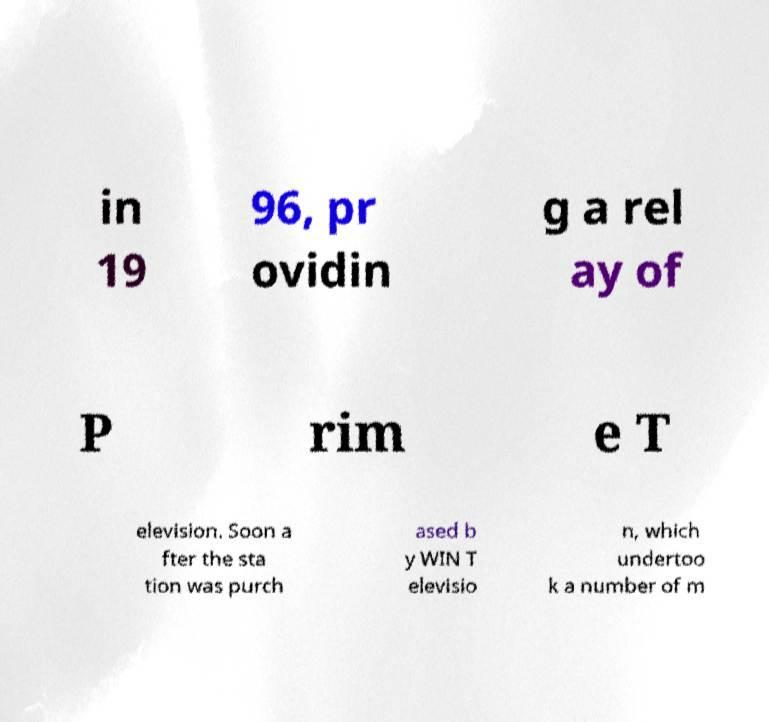Can you read and provide the text displayed in the image?This photo seems to have some interesting text. Can you extract and type it out for me? in 19 96, pr ovidin g a rel ay of P rim e T elevision. Soon a fter the sta tion was purch ased b y WIN T elevisio n, which undertoo k a number of m 